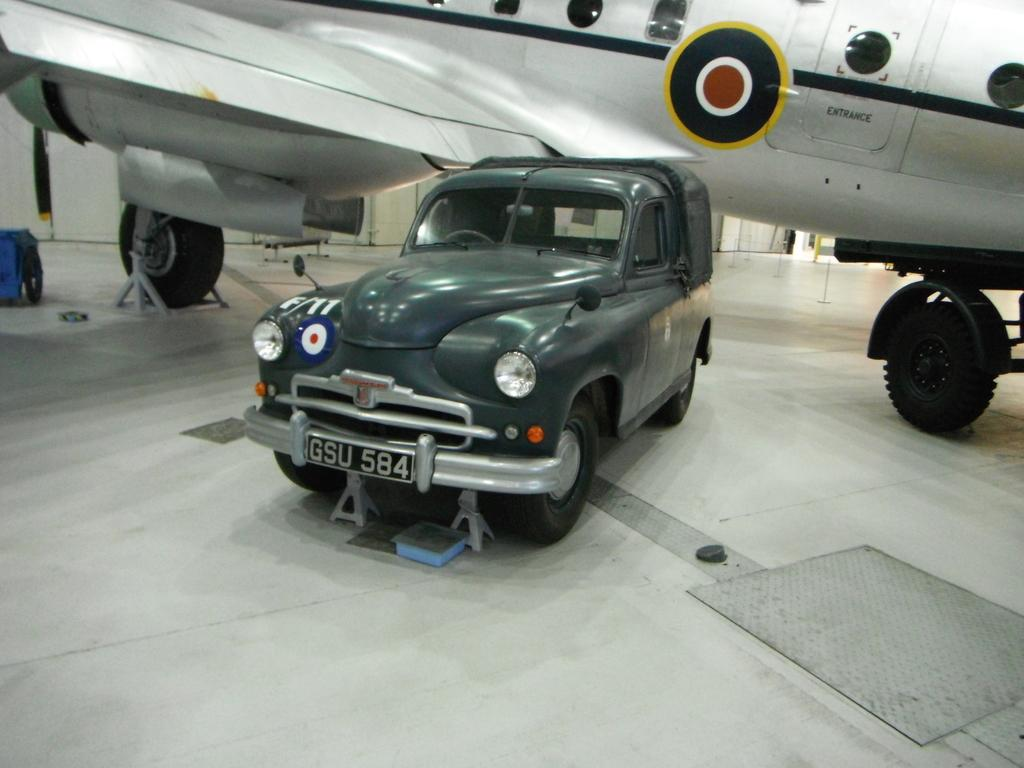What is the main subject in the image? There is a plane in the image. What other vehicle can be seen in the image? There is a car in the image. Can you describe the car in the image? The car has a number plate and headlights. What features of the plane can be seen in the image? The plane has windows, wheels, and a door. What is the color of the surface in the image? The surface in the image is white. What type of butter is being used to grease the vessel in the image? There is no butter or vessel present in the image. How does the wind affect the plane in the image? There is no wind present in the image, and the plane is stationary. 